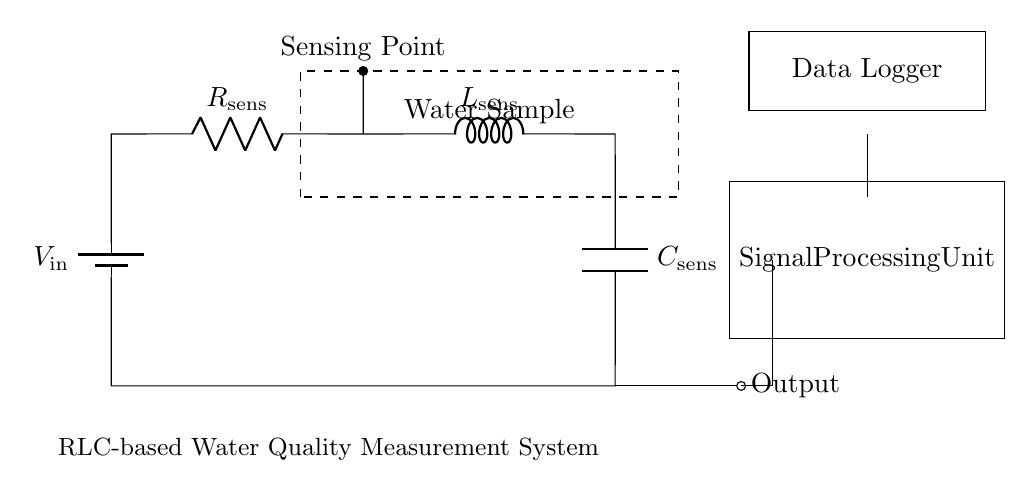What is the component labeled as V_in? The component labeled V_in is a voltage source that supplies power to the circuit.
Answer: voltage source What is the value of the resistor R_sens? The circuit diagram does not specify a numerical value for the resistor R_sens; it simply indicates that it is present.
Answer: not specified What do the dashed lines in the circuit represent? The dashed lines indicate the boundaries of the water sample area where measurements are taken.
Answer: water sample area How many components are used in this RLC circuit? The circuit contains three main components: one resistor, one inductor, and one capacitor, making a total of three.
Answer: three Which component connects the sensing point to the output? The output is connected through the capacitor, which is the last component in the circuit before the signal leaves the system.
Answer: capacitor What primary function does the signal processing unit serve? The signal processing unit is responsible for processing the signal received from the circuit for further analysis or action.
Answer: processing the signal Why is an RLC circuit suitable for measuring water quality? RLC circuits can accurately filter and respond to varying frequencies, making them ideal for detecting specific characteristics of water quality, such as conductivity or contaminants.
Answer: detecting characteristics 